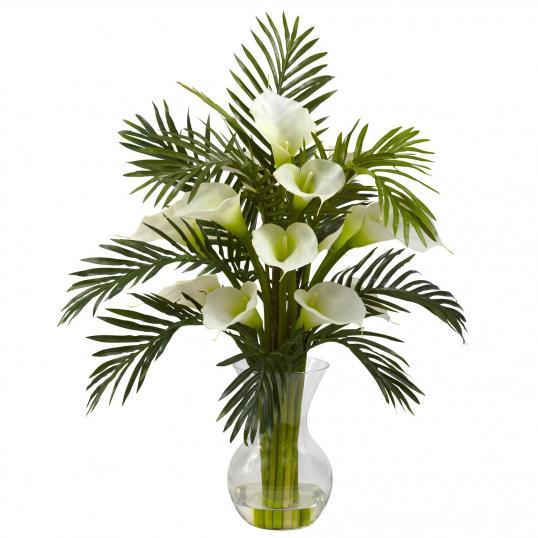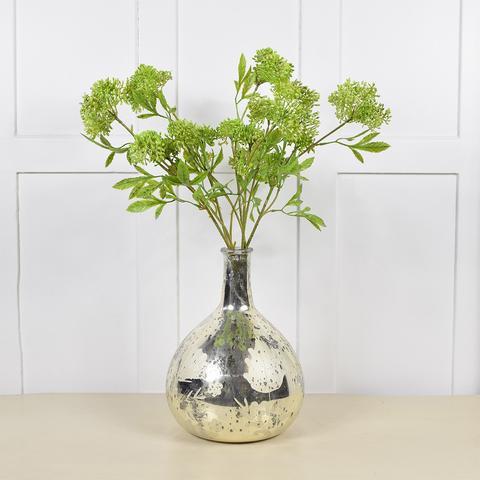The first image is the image on the left, the second image is the image on the right. Examine the images to the left and right. Is the description "In at least one image there is a vase wit the bottle looking metallic." accurate? Answer yes or no. Yes. The first image is the image on the left, the second image is the image on the right. Given the left and right images, does the statement "there is a vase of flowers sitting in front of a window" hold true? Answer yes or no. No. 